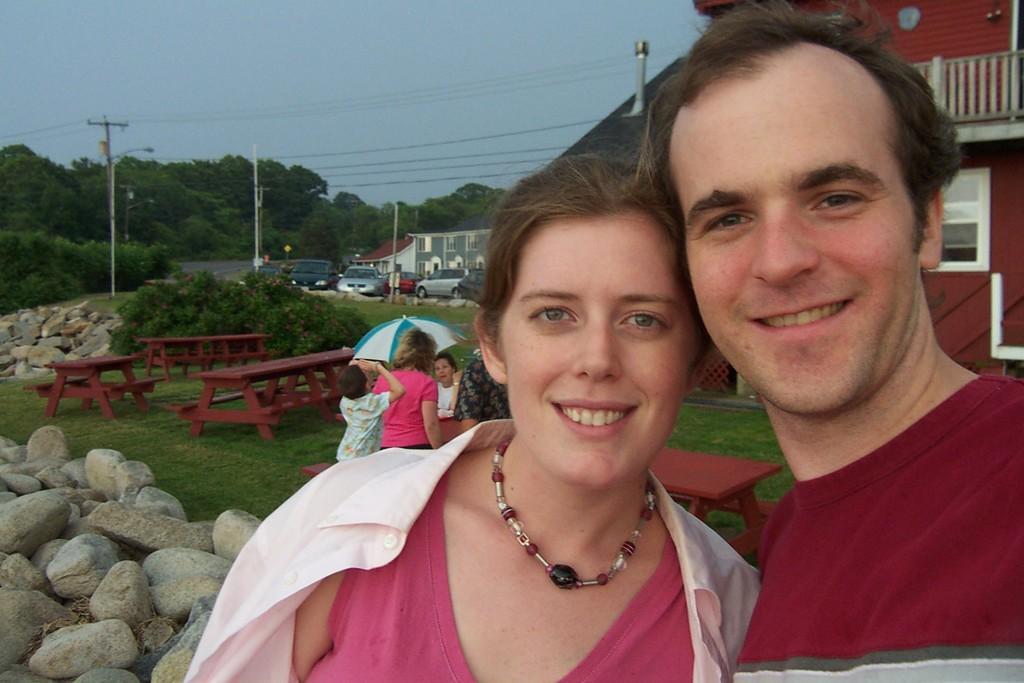Please provide a concise description of this image. In the foreground I can see two persons are standing on grass, a group of people are sitting on benches in front of a table and stones. In the background I can see planets, light poles, wires, buildings, vehicles on the road and the sky. This image is taken may be during a day. 